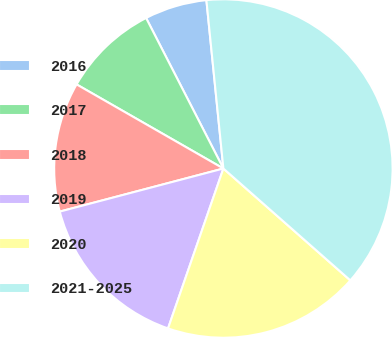<chart> <loc_0><loc_0><loc_500><loc_500><pie_chart><fcel>2016<fcel>2017<fcel>2018<fcel>2019<fcel>2020<fcel>2021-2025<nl><fcel>5.95%<fcel>9.17%<fcel>12.38%<fcel>15.6%<fcel>18.81%<fcel>38.1%<nl></chart> 